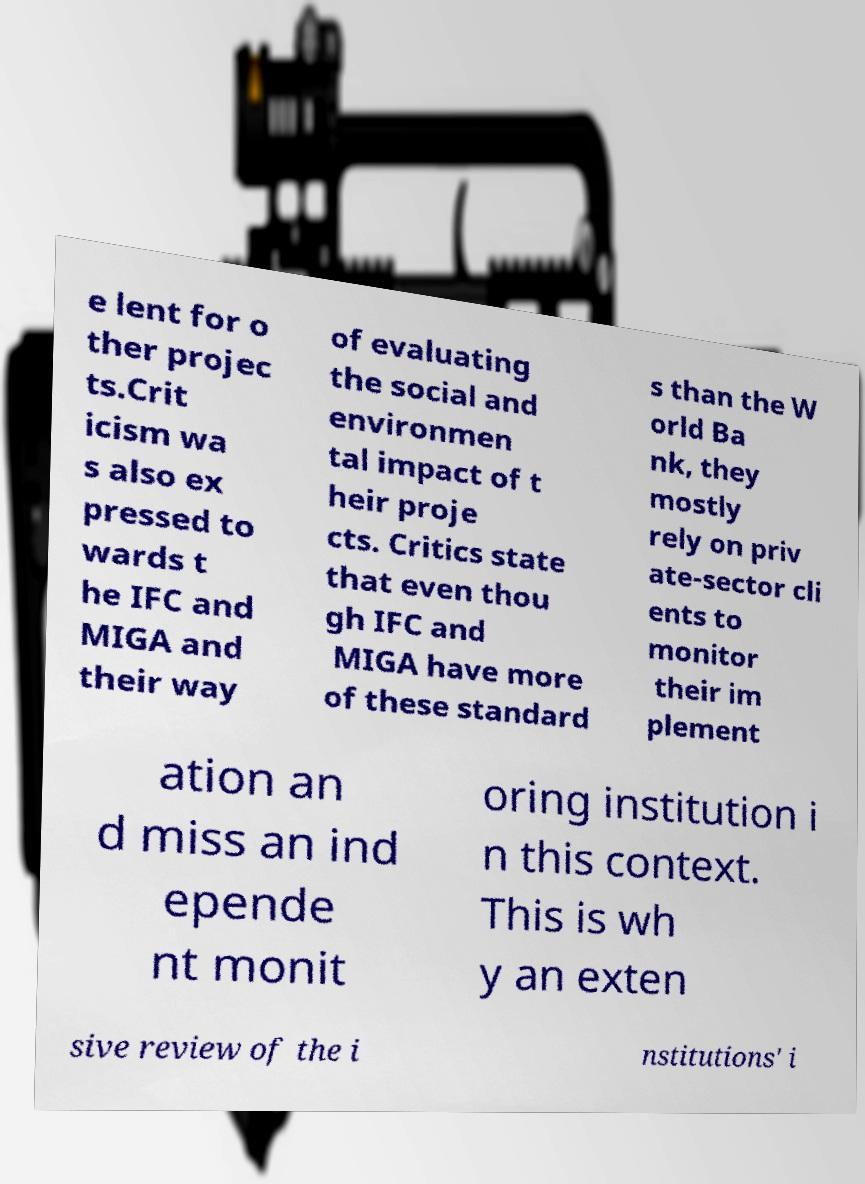Could you extract and type out the text from this image? e lent for o ther projec ts.Crit icism wa s also ex pressed to wards t he IFC and MIGA and their way of evaluating the social and environmen tal impact of t heir proje cts. Critics state that even thou gh IFC and MIGA have more of these standard s than the W orld Ba nk, they mostly rely on priv ate-sector cli ents to monitor their im plement ation an d miss an ind epende nt monit oring institution i n this context. This is wh y an exten sive review of the i nstitutions' i 